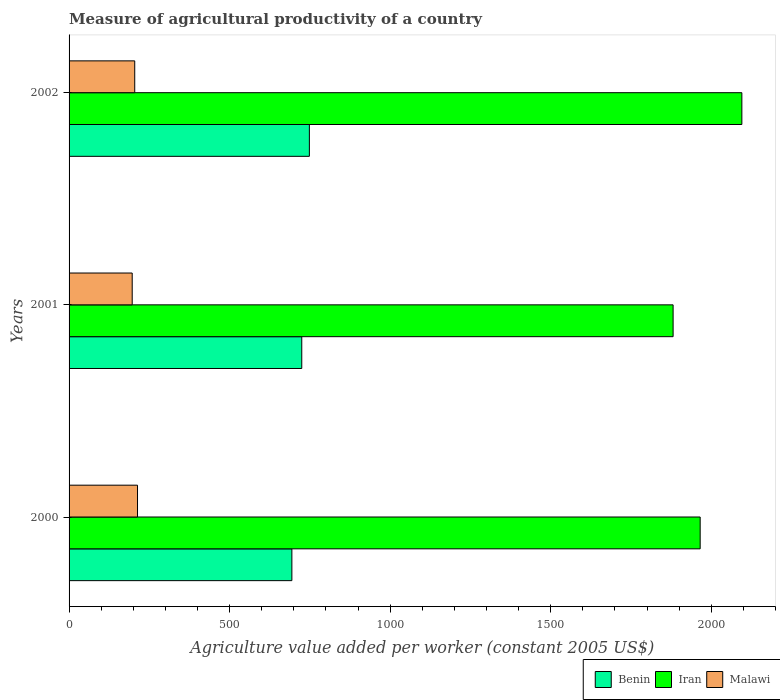How many groups of bars are there?
Keep it short and to the point. 3. How many bars are there on the 2nd tick from the top?
Ensure brevity in your answer.  3. What is the label of the 1st group of bars from the top?
Your response must be concise. 2002. What is the measure of agricultural productivity in Iran in 2002?
Give a very brief answer. 2095.42. Across all years, what is the maximum measure of agricultural productivity in Iran?
Provide a succinct answer. 2095.42. Across all years, what is the minimum measure of agricultural productivity in Benin?
Provide a short and direct response. 693.95. In which year was the measure of agricultural productivity in Iran maximum?
Offer a very short reply. 2002. In which year was the measure of agricultural productivity in Malawi minimum?
Provide a succinct answer. 2001. What is the total measure of agricultural productivity in Benin in the graph?
Offer a terse response. 2167.12. What is the difference between the measure of agricultural productivity in Benin in 2000 and that in 2001?
Offer a very short reply. -30.78. What is the difference between the measure of agricultural productivity in Benin in 2000 and the measure of agricultural productivity in Iran in 2002?
Offer a terse response. -1401.47. What is the average measure of agricultural productivity in Malawi per year?
Offer a very short reply. 204.78. In the year 2002, what is the difference between the measure of agricultural productivity in Iran and measure of agricultural productivity in Benin?
Your response must be concise. 1346.98. What is the ratio of the measure of agricultural productivity in Iran in 2001 to that in 2002?
Make the answer very short. 0.9. What is the difference between the highest and the second highest measure of agricultural productivity in Iran?
Make the answer very short. 129.81. What is the difference between the highest and the lowest measure of agricultural productivity in Iran?
Offer a very short reply. 214.13. What does the 3rd bar from the top in 2002 represents?
Your response must be concise. Benin. What does the 3rd bar from the bottom in 2000 represents?
Your answer should be compact. Malawi. How many bars are there?
Your response must be concise. 9. Does the graph contain grids?
Your answer should be very brief. No. Where does the legend appear in the graph?
Keep it short and to the point. Bottom right. How many legend labels are there?
Your answer should be very brief. 3. How are the legend labels stacked?
Provide a short and direct response. Horizontal. What is the title of the graph?
Your answer should be very brief. Measure of agricultural productivity of a country. What is the label or title of the X-axis?
Keep it short and to the point. Agriculture value added per worker (constant 2005 US$). What is the Agriculture value added per worker (constant 2005 US$) in Benin in 2000?
Ensure brevity in your answer.  693.95. What is the Agriculture value added per worker (constant 2005 US$) in Iran in 2000?
Provide a succinct answer. 1965.61. What is the Agriculture value added per worker (constant 2005 US$) in Malawi in 2000?
Ensure brevity in your answer.  213.16. What is the Agriculture value added per worker (constant 2005 US$) in Benin in 2001?
Your answer should be very brief. 724.73. What is the Agriculture value added per worker (constant 2005 US$) of Iran in 2001?
Keep it short and to the point. 1881.29. What is the Agriculture value added per worker (constant 2005 US$) in Malawi in 2001?
Provide a short and direct response. 196.64. What is the Agriculture value added per worker (constant 2005 US$) in Benin in 2002?
Your response must be concise. 748.44. What is the Agriculture value added per worker (constant 2005 US$) of Iran in 2002?
Ensure brevity in your answer.  2095.42. What is the Agriculture value added per worker (constant 2005 US$) of Malawi in 2002?
Provide a short and direct response. 204.53. Across all years, what is the maximum Agriculture value added per worker (constant 2005 US$) of Benin?
Your answer should be very brief. 748.44. Across all years, what is the maximum Agriculture value added per worker (constant 2005 US$) of Iran?
Provide a short and direct response. 2095.42. Across all years, what is the maximum Agriculture value added per worker (constant 2005 US$) of Malawi?
Offer a terse response. 213.16. Across all years, what is the minimum Agriculture value added per worker (constant 2005 US$) in Benin?
Provide a succinct answer. 693.95. Across all years, what is the minimum Agriculture value added per worker (constant 2005 US$) in Iran?
Offer a terse response. 1881.29. Across all years, what is the minimum Agriculture value added per worker (constant 2005 US$) of Malawi?
Your answer should be very brief. 196.64. What is the total Agriculture value added per worker (constant 2005 US$) of Benin in the graph?
Your answer should be very brief. 2167.12. What is the total Agriculture value added per worker (constant 2005 US$) in Iran in the graph?
Provide a succinct answer. 5942.33. What is the total Agriculture value added per worker (constant 2005 US$) in Malawi in the graph?
Keep it short and to the point. 614.33. What is the difference between the Agriculture value added per worker (constant 2005 US$) in Benin in 2000 and that in 2001?
Your response must be concise. -30.78. What is the difference between the Agriculture value added per worker (constant 2005 US$) in Iran in 2000 and that in 2001?
Give a very brief answer. 84.32. What is the difference between the Agriculture value added per worker (constant 2005 US$) of Malawi in 2000 and that in 2001?
Make the answer very short. 16.53. What is the difference between the Agriculture value added per worker (constant 2005 US$) in Benin in 2000 and that in 2002?
Ensure brevity in your answer.  -54.5. What is the difference between the Agriculture value added per worker (constant 2005 US$) in Iran in 2000 and that in 2002?
Offer a very short reply. -129.81. What is the difference between the Agriculture value added per worker (constant 2005 US$) in Malawi in 2000 and that in 2002?
Offer a terse response. 8.64. What is the difference between the Agriculture value added per worker (constant 2005 US$) of Benin in 2001 and that in 2002?
Offer a very short reply. -23.71. What is the difference between the Agriculture value added per worker (constant 2005 US$) in Iran in 2001 and that in 2002?
Offer a terse response. -214.13. What is the difference between the Agriculture value added per worker (constant 2005 US$) in Malawi in 2001 and that in 2002?
Provide a succinct answer. -7.89. What is the difference between the Agriculture value added per worker (constant 2005 US$) of Benin in 2000 and the Agriculture value added per worker (constant 2005 US$) of Iran in 2001?
Your response must be concise. -1187.34. What is the difference between the Agriculture value added per worker (constant 2005 US$) in Benin in 2000 and the Agriculture value added per worker (constant 2005 US$) in Malawi in 2001?
Your answer should be compact. 497.31. What is the difference between the Agriculture value added per worker (constant 2005 US$) of Iran in 2000 and the Agriculture value added per worker (constant 2005 US$) of Malawi in 2001?
Ensure brevity in your answer.  1768.98. What is the difference between the Agriculture value added per worker (constant 2005 US$) of Benin in 2000 and the Agriculture value added per worker (constant 2005 US$) of Iran in 2002?
Your answer should be compact. -1401.47. What is the difference between the Agriculture value added per worker (constant 2005 US$) of Benin in 2000 and the Agriculture value added per worker (constant 2005 US$) of Malawi in 2002?
Make the answer very short. 489.42. What is the difference between the Agriculture value added per worker (constant 2005 US$) of Iran in 2000 and the Agriculture value added per worker (constant 2005 US$) of Malawi in 2002?
Your answer should be compact. 1761.09. What is the difference between the Agriculture value added per worker (constant 2005 US$) in Benin in 2001 and the Agriculture value added per worker (constant 2005 US$) in Iran in 2002?
Offer a very short reply. -1370.69. What is the difference between the Agriculture value added per worker (constant 2005 US$) of Benin in 2001 and the Agriculture value added per worker (constant 2005 US$) of Malawi in 2002?
Offer a very short reply. 520.2. What is the difference between the Agriculture value added per worker (constant 2005 US$) in Iran in 2001 and the Agriculture value added per worker (constant 2005 US$) in Malawi in 2002?
Keep it short and to the point. 1676.76. What is the average Agriculture value added per worker (constant 2005 US$) of Benin per year?
Ensure brevity in your answer.  722.37. What is the average Agriculture value added per worker (constant 2005 US$) in Iran per year?
Ensure brevity in your answer.  1980.78. What is the average Agriculture value added per worker (constant 2005 US$) of Malawi per year?
Give a very brief answer. 204.78. In the year 2000, what is the difference between the Agriculture value added per worker (constant 2005 US$) in Benin and Agriculture value added per worker (constant 2005 US$) in Iran?
Provide a short and direct response. -1271.67. In the year 2000, what is the difference between the Agriculture value added per worker (constant 2005 US$) in Benin and Agriculture value added per worker (constant 2005 US$) in Malawi?
Your answer should be very brief. 480.78. In the year 2000, what is the difference between the Agriculture value added per worker (constant 2005 US$) in Iran and Agriculture value added per worker (constant 2005 US$) in Malawi?
Make the answer very short. 1752.45. In the year 2001, what is the difference between the Agriculture value added per worker (constant 2005 US$) of Benin and Agriculture value added per worker (constant 2005 US$) of Iran?
Offer a very short reply. -1156.56. In the year 2001, what is the difference between the Agriculture value added per worker (constant 2005 US$) in Benin and Agriculture value added per worker (constant 2005 US$) in Malawi?
Your response must be concise. 528.09. In the year 2001, what is the difference between the Agriculture value added per worker (constant 2005 US$) in Iran and Agriculture value added per worker (constant 2005 US$) in Malawi?
Your response must be concise. 1684.66. In the year 2002, what is the difference between the Agriculture value added per worker (constant 2005 US$) in Benin and Agriculture value added per worker (constant 2005 US$) in Iran?
Provide a succinct answer. -1346.98. In the year 2002, what is the difference between the Agriculture value added per worker (constant 2005 US$) in Benin and Agriculture value added per worker (constant 2005 US$) in Malawi?
Offer a terse response. 543.92. In the year 2002, what is the difference between the Agriculture value added per worker (constant 2005 US$) of Iran and Agriculture value added per worker (constant 2005 US$) of Malawi?
Your response must be concise. 1890.89. What is the ratio of the Agriculture value added per worker (constant 2005 US$) in Benin in 2000 to that in 2001?
Ensure brevity in your answer.  0.96. What is the ratio of the Agriculture value added per worker (constant 2005 US$) in Iran in 2000 to that in 2001?
Offer a very short reply. 1.04. What is the ratio of the Agriculture value added per worker (constant 2005 US$) in Malawi in 2000 to that in 2001?
Give a very brief answer. 1.08. What is the ratio of the Agriculture value added per worker (constant 2005 US$) of Benin in 2000 to that in 2002?
Your answer should be compact. 0.93. What is the ratio of the Agriculture value added per worker (constant 2005 US$) in Iran in 2000 to that in 2002?
Give a very brief answer. 0.94. What is the ratio of the Agriculture value added per worker (constant 2005 US$) in Malawi in 2000 to that in 2002?
Ensure brevity in your answer.  1.04. What is the ratio of the Agriculture value added per worker (constant 2005 US$) of Benin in 2001 to that in 2002?
Ensure brevity in your answer.  0.97. What is the ratio of the Agriculture value added per worker (constant 2005 US$) of Iran in 2001 to that in 2002?
Your answer should be compact. 0.9. What is the ratio of the Agriculture value added per worker (constant 2005 US$) in Malawi in 2001 to that in 2002?
Your answer should be very brief. 0.96. What is the difference between the highest and the second highest Agriculture value added per worker (constant 2005 US$) of Benin?
Your answer should be compact. 23.71. What is the difference between the highest and the second highest Agriculture value added per worker (constant 2005 US$) in Iran?
Make the answer very short. 129.81. What is the difference between the highest and the second highest Agriculture value added per worker (constant 2005 US$) of Malawi?
Make the answer very short. 8.64. What is the difference between the highest and the lowest Agriculture value added per worker (constant 2005 US$) in Benin?
Ensure brevity in your answer.  54.5. What is the difference between the highest and the lowest Agriculture value added per worker (constant 2005 US$) in Iran?
Make the answer very short. 214.13. What is the difference between the highest and the lowest Agriculture value added per worker (constant 2005 US$) in Malawi?
Your answer should be compact. 16.53. 